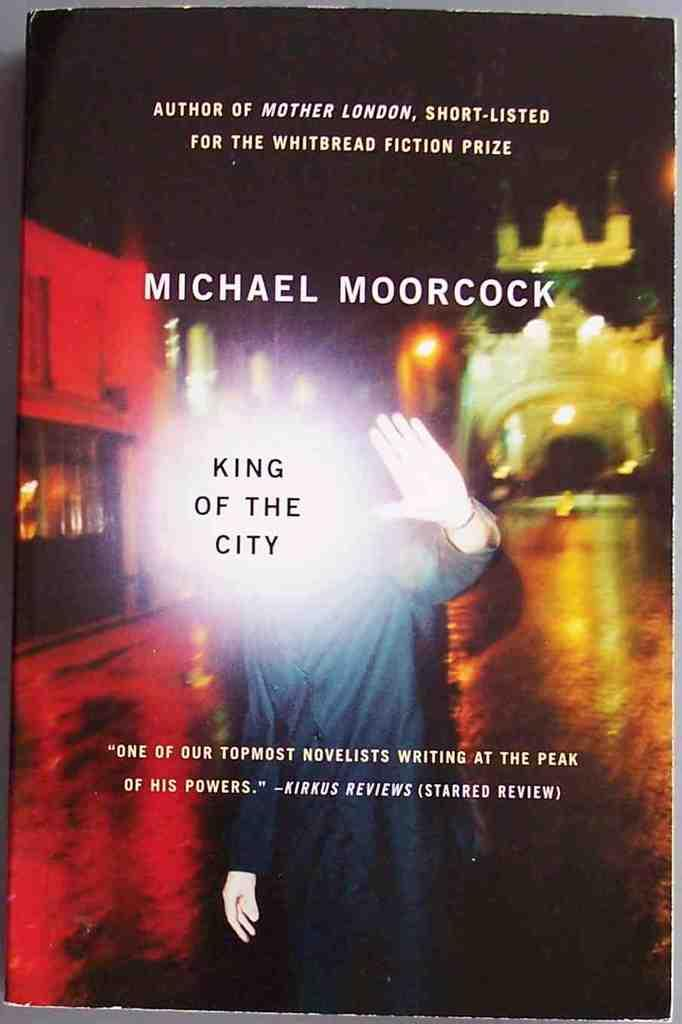<image>
Present a compact description of the photo's key features. The King of the City book cover written by Michael Moorcock. 